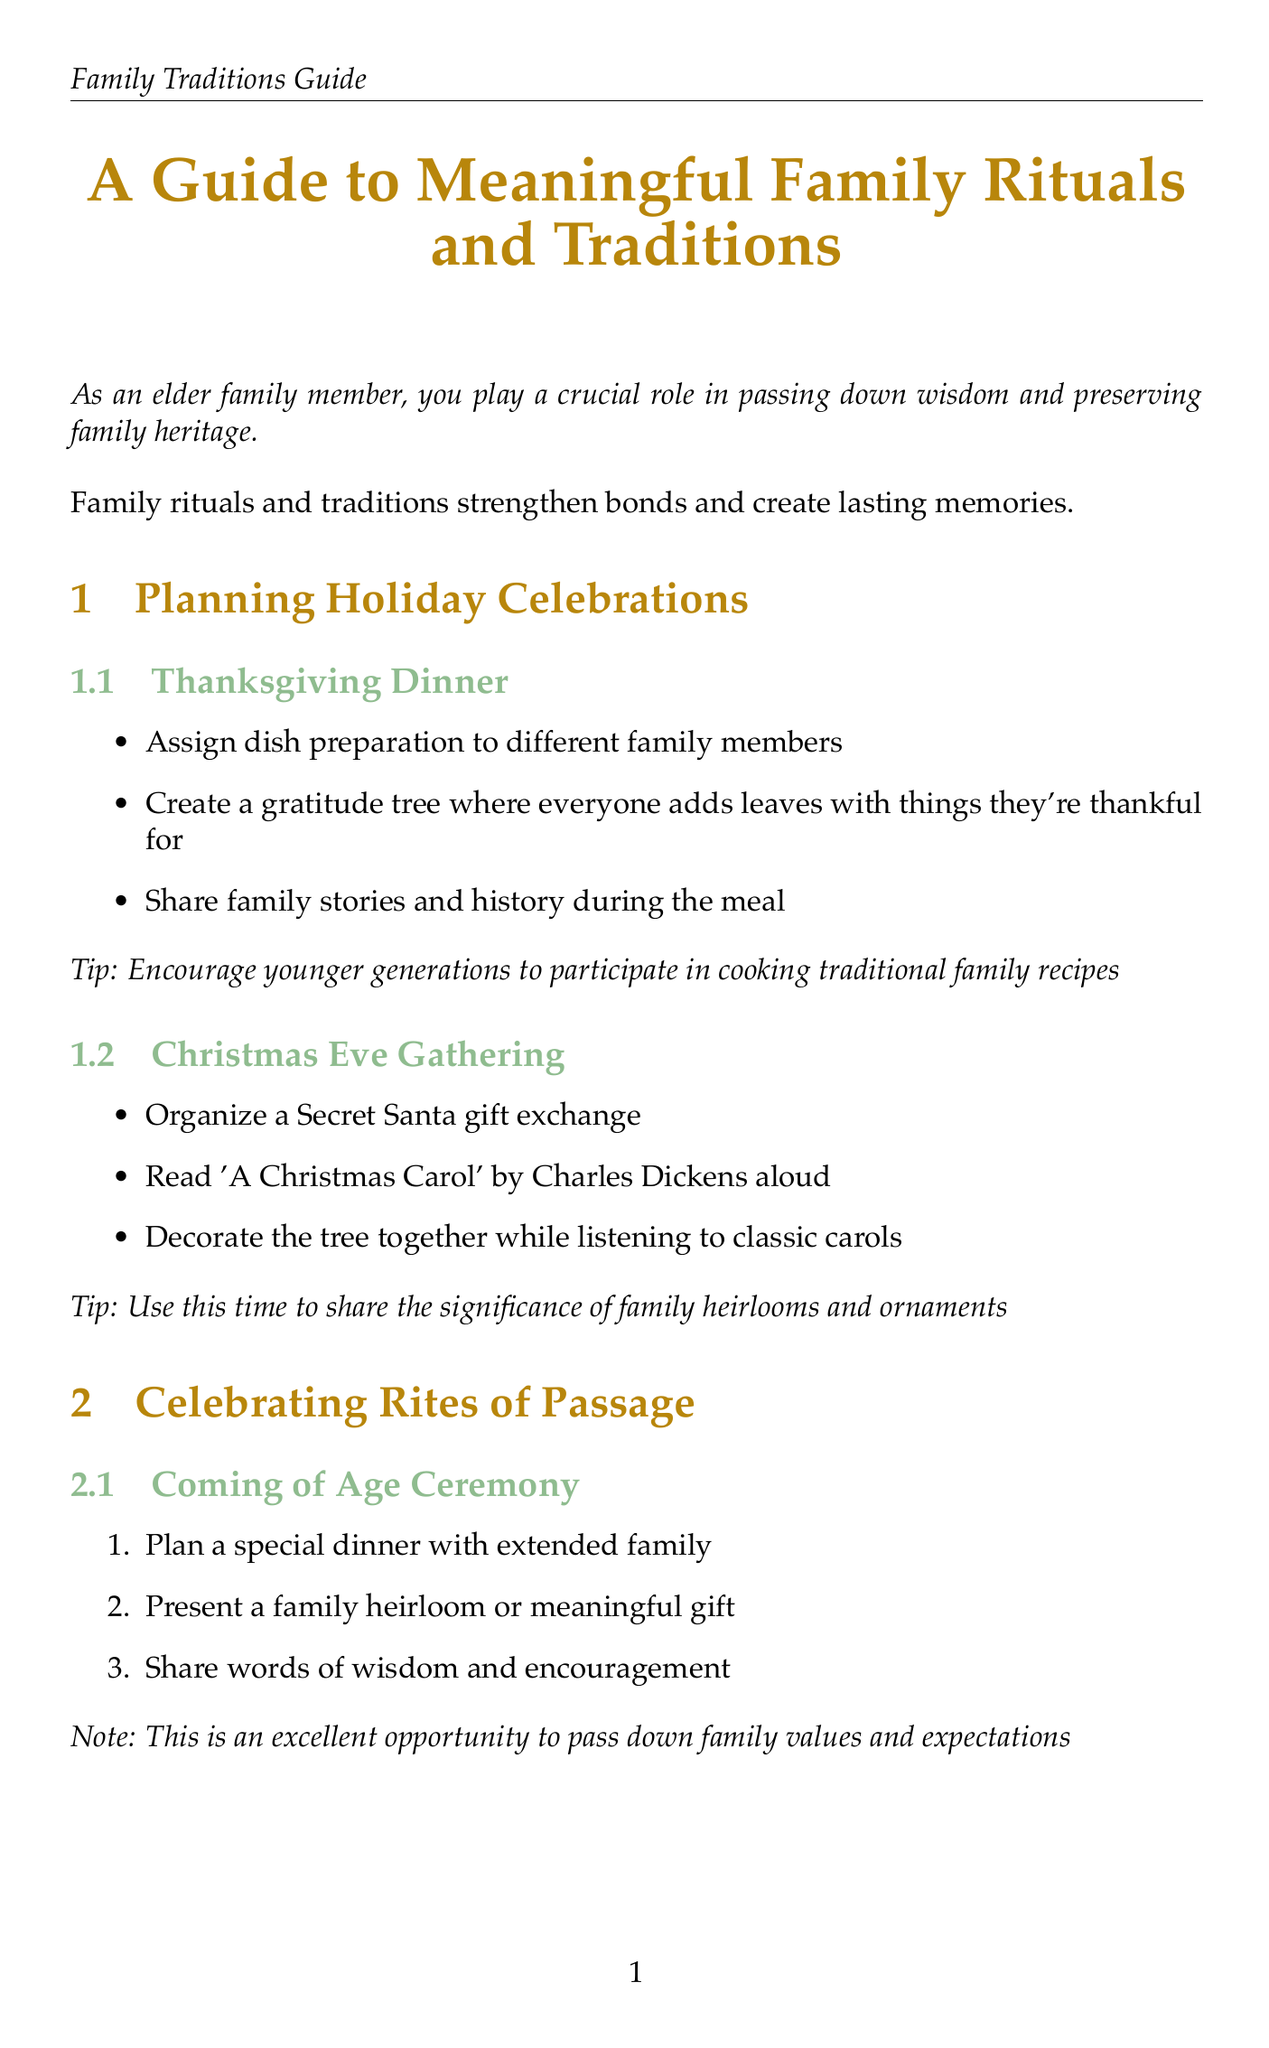what is the main purpose of family rituals and traditions? The document states that family rituals and traditions strengthen bonds and create lasting memories.
Answer: strengthen bonds and create lasting memories what activity is suggested for Thanksgiving Dinner? One of the activities mentioned for Thanksgiving Dinner is to create a gratitude tree where everyone adds leaves with things they're thankful for.
Answer: create a gratitude tree who is encouraged to participate in cooking traditional family recipes? The document notes to encourage younger generations to participate in cooking traditional family recipes during Thanksgiving.
Answer: younger generations what is one guideline for Sunday Dinner? One guideline for Sunday Dinner is to start with a prayer or moment of gratitude.
Answer: start with a prayer or moment of gratitude what type of games are suggested for Family Game Night? The document suggests choosing classic board games like Monopoly, Scrabble, or Clue for Family Game Night.
Answer: classic board games what is the suggested activity for a Coming of Age Ceremony? The document suggests planning a special dinner with extended family for a Coming of Age Ceremony.
Answer: special dinner with extended family what should family members share during Graduation Celebration? Family members should share a piece of life advice during Graduation Celebration.
Answer: piece of life advice what is emphasized about education in the context of Graduation Celebration? The document emphasizes the importance of education and lifelong learning during the Graduation Celebration.
Answer: importance of education and lifelong learning how should the family tree be created? The document suggests gathering old photographs and documents as part of creating a family tree.
Answer: gathering old photographs and documents 